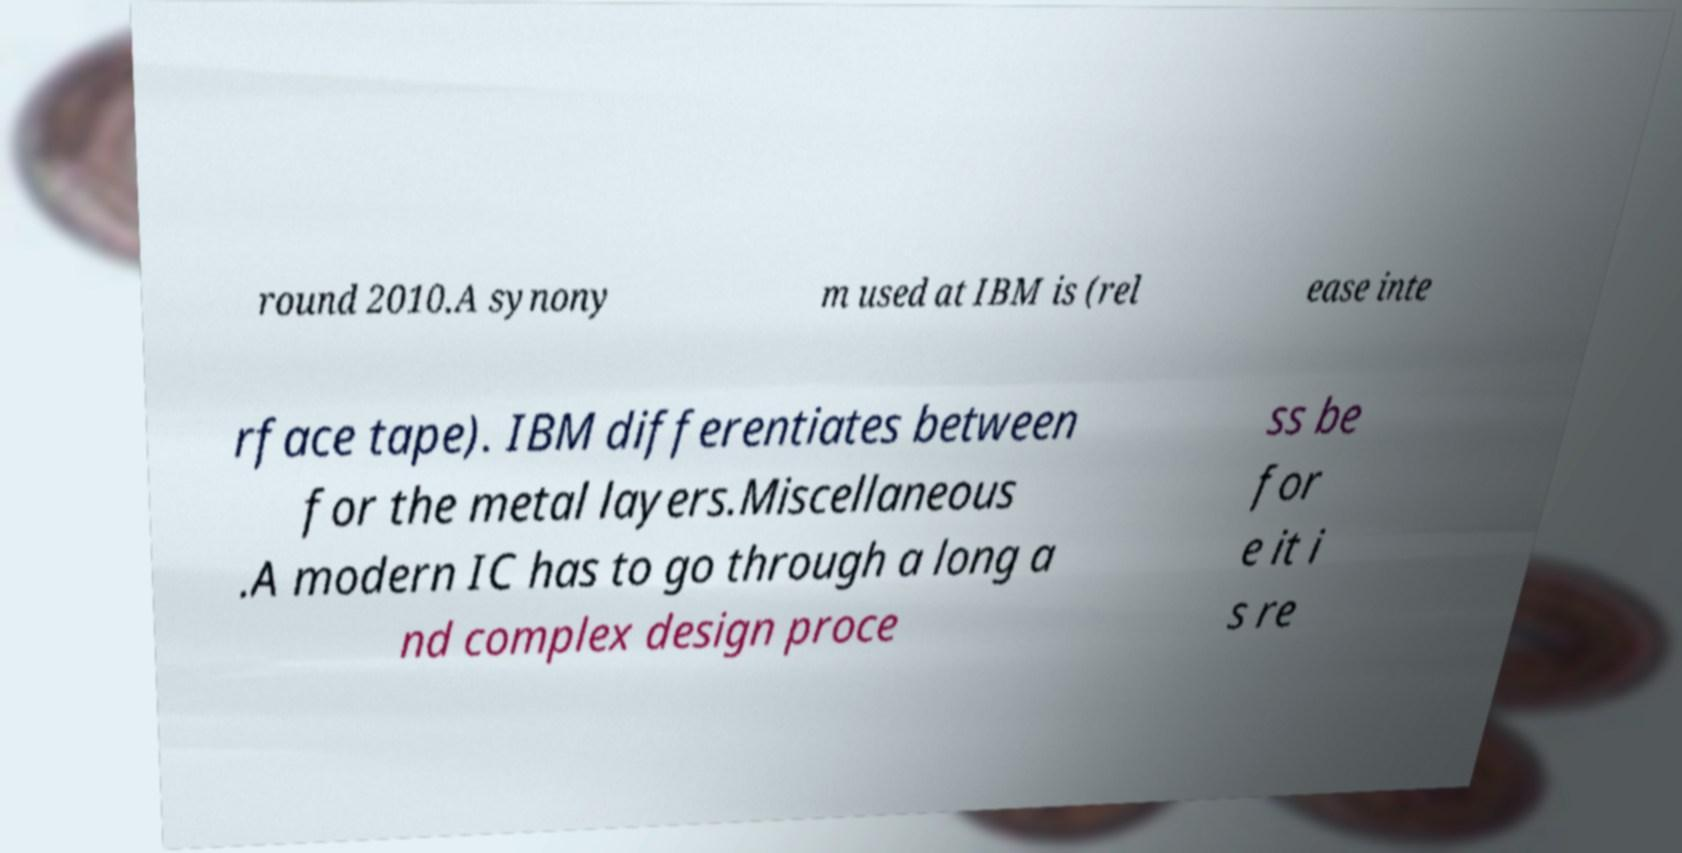What messages or text are displayed in this image? I need them in a readable, typed format. round 2010.A synony m used at IBM is (rel ease inte rface tape). IBM differentiates between for the metal layers.Miscellaneous .A modern IC has to go through a long a nd complex design proce ss be for e it i s re 